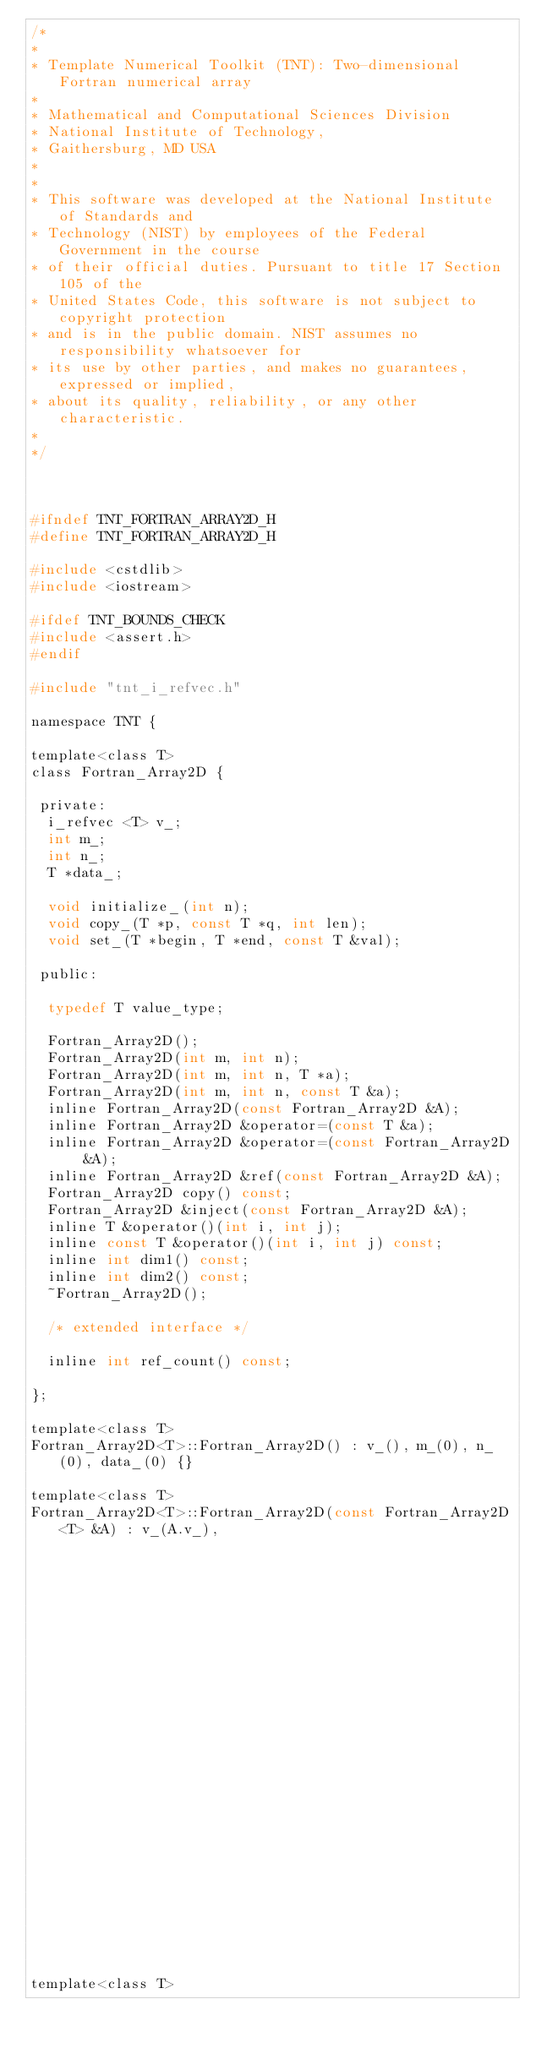<code> <loc_0><loc_0><loc_500><loc_500><_C_>/*
*
* Template Numerical Toolkit (TNT): Two-dimensional Fortran numerical array
*
* Mathematical and Computational Sciences Division
* National Institute of Technology,
* Gaithersburg, MD USA
*
*
* This software was developed at the National Institute of Standards and
* Technology (NIST) by employees of the Federal Government in the course
* of their official duties. Pursuant to title 17 Section 105 of the
* United States Code, this software is not subject to copyright protection
* and is in the public domain. NIST assumes no responsibility whatsoever for
* its use by other parties, and makes no guarantees, expressed or implied,
* about its quality, reliability, or any other characteristic.
*
*/



#ifndef TNT_FORTRAN_ARRAY2D_H
#define TNT_FORTRAN_ARRAY2D_H

#include <cstdlib>
#include <iostream>

#ifdef TNT_BOUNDS_CHECK
#include <assert.h>
#endif

#include "tnt_i_refvec.h"

namespace TNT {

template<class T>
class Fortran_Array2D {

 private:
  i_refvec <T> v_;
  int m_;
  int n_;
  T *data_;

  void initialize_(int n);
  void copy_(T *p, const T *q, int len);
  void set_(T *begin, T *end, const T &val);

 public:

  typedef T value_type;

  Fortran_Array2D();
  Fortran_Array2D(int m, int n);
  Fortran_Array2D(int m, int n, T *a);
  Fortran_Array2D(int m, int n, const T &a);
  inline Fortran_Array2D(const Fortran_Array2D &A);
  inline Fortran_Array2D &operator=(const T &a);
  inline Fortran_Array2D &operator=(const Fortran_Array2D &A);
  inline Fortran_Array2D &ref(const Fortran_Array2D &A);
  Fortran_Array2D copy() const;
  Fortran_Array2D &inject(const Fortran_Array2D &A);
  inline T &operator()(int i, int j);
  inline const T &operator()(int i, int j) const;
  inline int dim1() const;
  inline int dim2() const;
  ~Fortran_Array2D();

  /* extended interface */

  inline int ref_count() const;

};

template<class T>
Fortran_Array2D<T>::Fortran_Array2D() : v_(), m_(0), n_(0), data_(0) {}

template<class T>
Fortran_Array2D<T>::Fortran_Array2D(const Fortran_Array2D<T> &A) : v_(A.v_),
                                                                   m_(A.m_), n_(A.n_), data_(A.data_) {}

template<class T></code> 